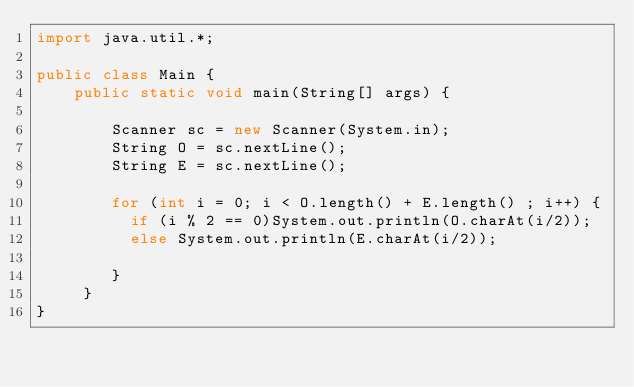Convert code to text. <code><loc_0><loc_0><loc_500><loc_500><_Java_>import java.util.*;
 
public class Main {
    public static void main(String[] args) {
 
        Scanner sc = new Scanner(System.in);
        String O = sc.nextLine();
        String E = sc.nextLine();
        
        for (int i = 0; i < O.length() + E.length() ; i++) {
          if (i % 2 == 0)System.out.println(O.charAt(i/2));
          else System.out.println(E.charAt(i/2));
         
        }
     }
}</code> 